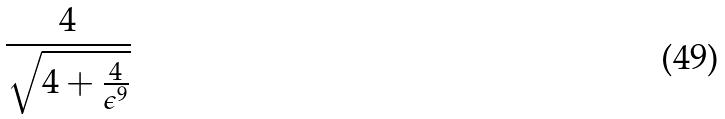Convert formula to latex. <formula><loc_0><loc_0><loc_500><loc_500>\frac { 4 } { \sqrt { 4 + \frac { 4 } { \epsilon ^ { 9 } } } }</formula> 